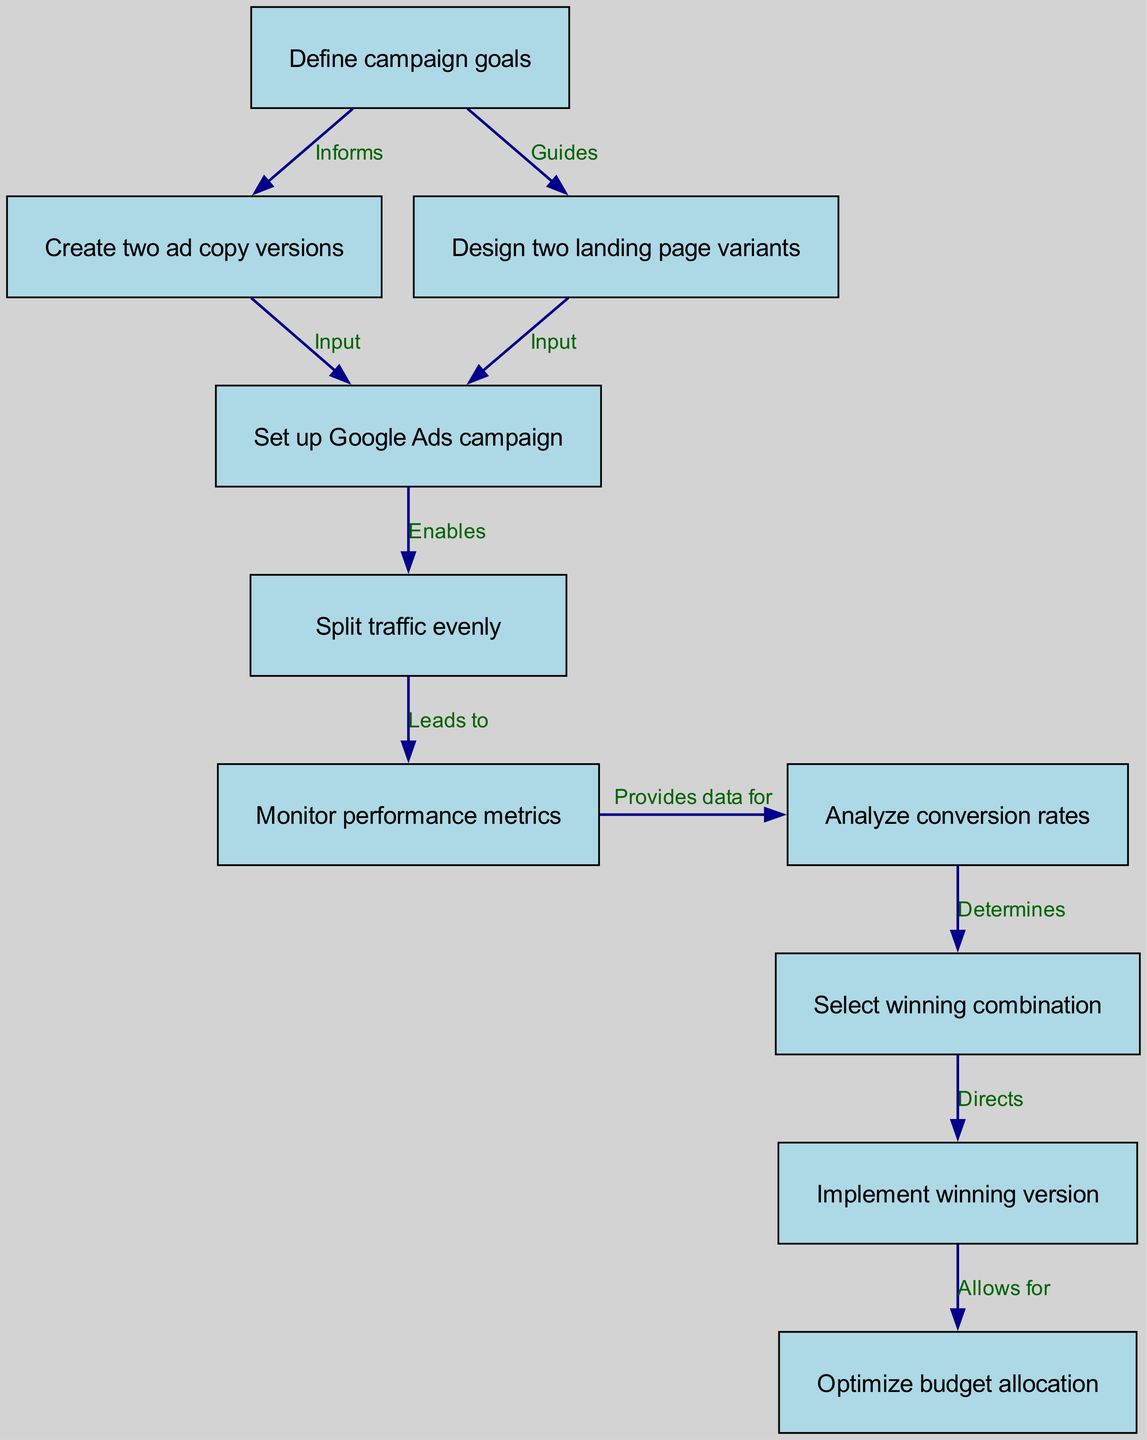What is the first step in the A/B testing process? The first node in the diagram is labeled "Define campaign goals", which indicates it is the initial step to start the process.
Answer: Define campaign goals How many nodes are in the diagram? The diagram consists of 10 nodes, as each defined node is listed before the edges, clearly identifying separate components of the process.
Answer: 10 What action does "Monitor performance metrics" directly lead to? From the diagram, "Monitor performance metrics" is seen to lead directly to "Analyze conversion rates" based on the edge connecting the two nodes.
Answer: Analyze conversion rates What does "Create two ad copy versions" inform? The edge from "Define campaign goals" to "Create two ad copy versions" indicates that the creation of ad copies is informed by the established campaign goals.
Answer: Define campaign goals Which node represents the implementation of the winning version? The node labeled "Implement winning version" signifies the action taken after selecting the optimal combination based on the analysis of conversion rates.
Answer: Implement winning version What two nodes are inputs for the "Set up Google Ads campaign"? The nodes "Create two ad copy versions" and "Design two landing page variants" both serve as inputs to the action "Set up Google Ads campaign" in the diagram.
Answer: Create two ad copy versions, Design two landing page variants What directly allows for budget allocation optimization? The diagram shows that "Implement winning version" directly allows for "Optimize budget allocation," indicating that after implementing the best-performing version, budget refinement occurs.
Answer: Optimize budget allocation What determines the winning combination? "Analyze conversion rates" is responsible for determining the winning combination based on the data collected from monitoring performance metrics.
Answer: Analyze conversion rates What is the relationship between "Split traffic evenly" and "Monitor performance metrics"? The relationship is indicated by the edge connecting "Split traffic evenly" to "Monitor performance metrics," suggesting that the setup of traffic distribution will lead to performance monitoring after the campaign is active.
Answer: Leads to 